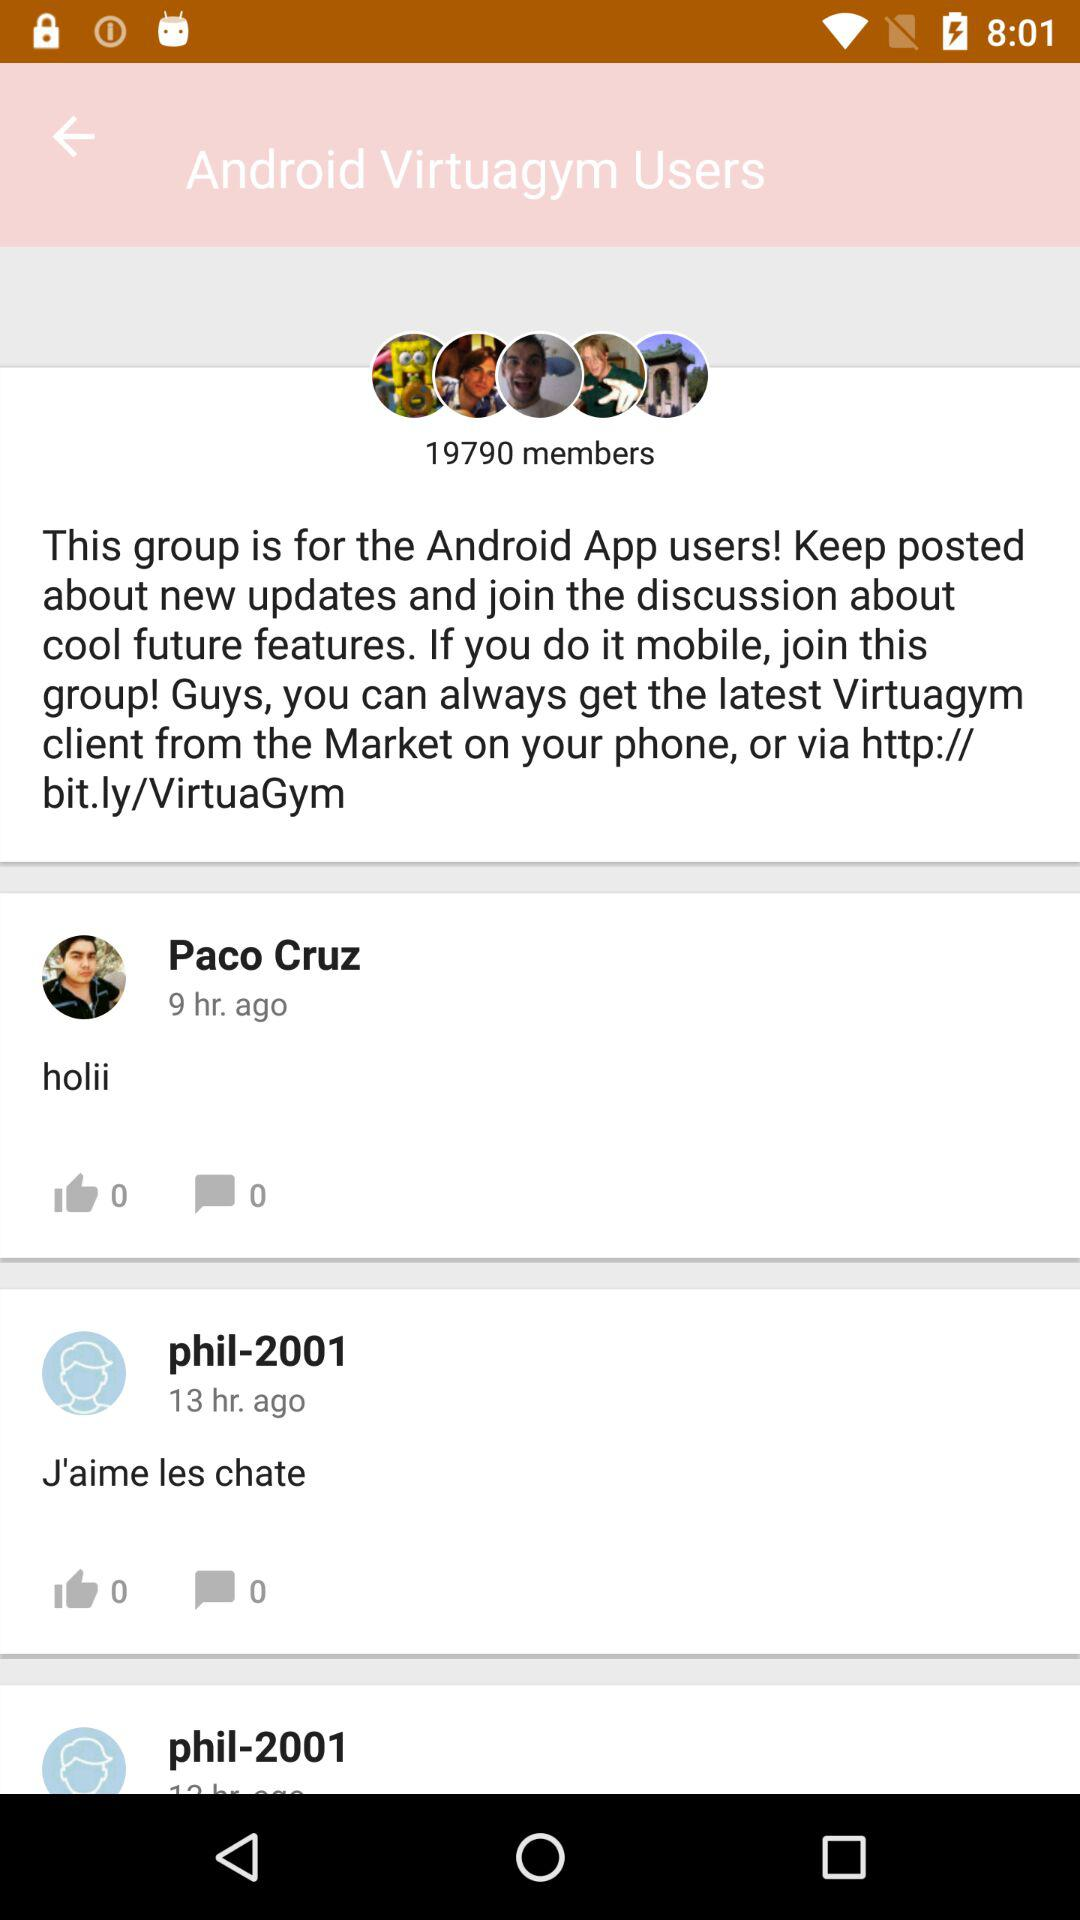How many likes are on Paco Cruz's post? There are 0 likes. 